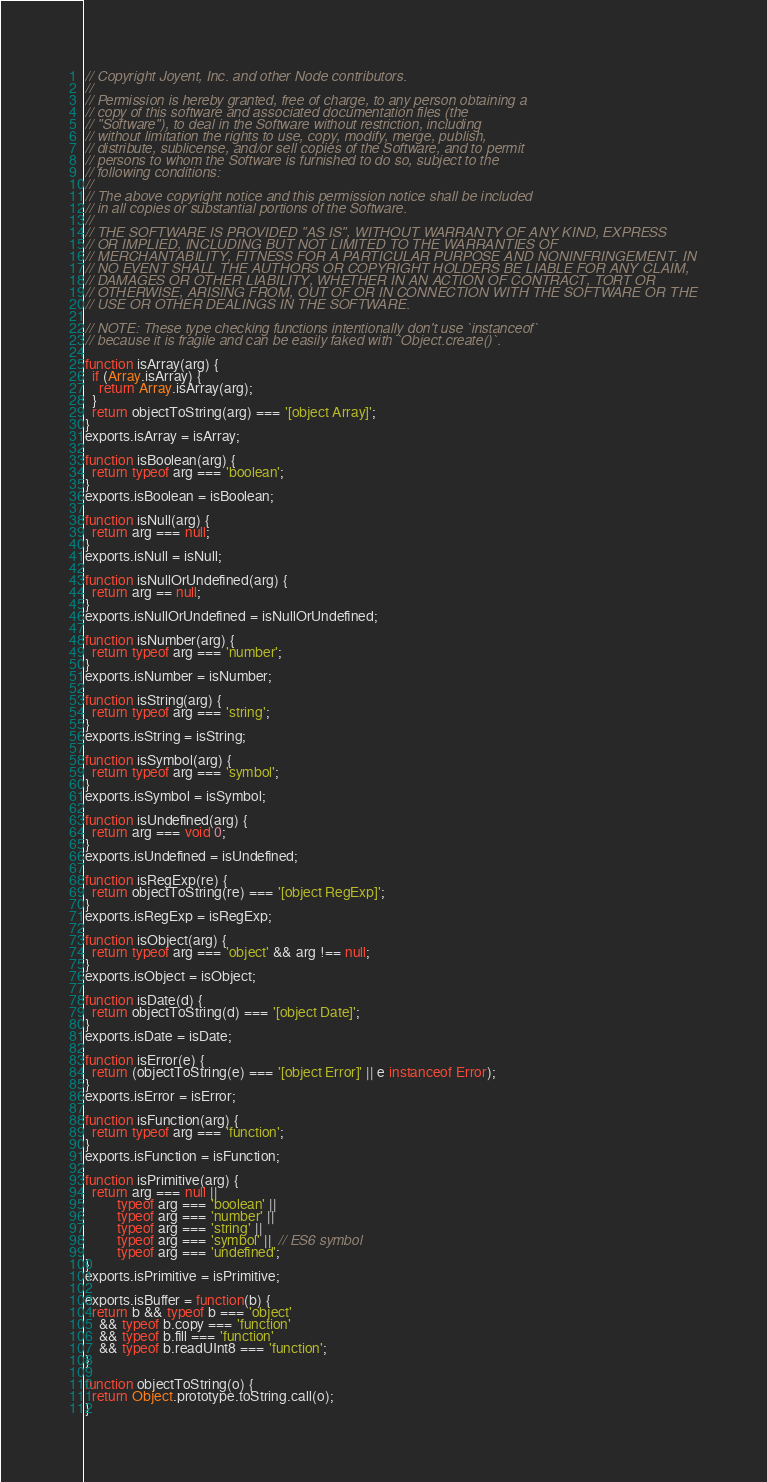Convert code to text. <code><loc_0><loc_0><loc_500><loc_500><_JavaScript_>// Copyright Joyent, Inc. and other Node contributors.
//
// Permission is hereby granted, free of charge, to any person obtaining a
// copy of this software and associated documentation files (the
// "Software"), to deal in the Software without restriction, including
// without limitation the rights to use, copy, modify, merge, publish,
// distribute, sublicense, and/or sell copies of the Software, and to permit
// persons to whom the Software is furnished to do so, subject to the
// following conditions:
//
// The above copyright notice and this permission notice shall be included
// in all copies or substantial portions of the Software.
//
// THE SOFTWARE IS PROVIDED "AS IS", WITHOUT WARRANTY OF ANY KIND, EXPRESS
// OR IMPLIED, INCLUDING BUT NOT LIMITED TO THE WARRANTIES OF
// MERCHANTABILITY, FITNESS FOR A PARTICULAR PURPOSE AND NONINFRINGEMENT. IN
// NO EVENT SHALL THE AUTHORS OR COPYRIGHT HOLDERS BE LIABLE FOR ANY CLAIM,
// DAMAGES OR OTHER LIABILITY, WHETHER IN AN ACTION OF CONTRACT, TORT OR
// OTHERWISE, ARISING FROM, OUT OF OR IN CONNECTION WITH THE SOFTWARE OR THE
// USE OR OTHER DEALINGS IN THE SOFTWARE.

// NOTE: These type checking functions intentionally don't use `instanceof`
// because it is fragile and can be easily faked with `Object.create()`.

function isArray(arg) {
  if (Array.isArray) {
    return Array.isArray(arg);
  }
  return objectToString(arg) === '[object Array]';
}
exports.isArray = isArray;

function isBoolean(arg) {
  return typeof arg === 'boolean';
}
exports.isBoolean = isBoolean;

function isNull(arg) {
  return arg === null;
}
exports.isNull = isNull;

function isNullOrUndefined(arg) {
  return arg == null;
}
exports.isNullOrUndefined = isNullOrUndefined;

function isNumber(arg) {
  return typeof arg === 'number';
}
exports.isNumber = isNumber;

function isString(arg) {
  return typeof arg === 'string';
}
exports.isString = isString;

function isSymbol(arg) {
  return typeof arg === 'symbol';
}
exports.isSymbol = isSymbol;

function isUndefined(arg) {
  return arg === void 0;
}
exports.isUndefined = isUndefined;

function isRegExp(re) {
  return objectToString(re) === '[object RegExp]';
}
exports.isRegExp = isRegExp;

function isObject(arg) {
  return typeof arg === 'object' && arg !== null;
}
exports.isObject = isObject;

function isDate(d) {
  return objectToString(d) === '[object Date]';
}
exports.isDate = isDate;

function isError(e) {
  return (objectToString(e) === '[object Error]' || e instanceof Error);
}
exports.isError = isError;

function isFunction(arg) {
  return typeof arg === 'function';
}
exports.isFunction = isFunction;

function isPrimitive(arg) {
  return arg === null ||
         typeof arg === 'boolean' ||
         typeof arg === 'number' ||
         typeof arg === 'string' ||
         typeof arg === 'symbol' ||  // ES6 symbol
         typeof arg === 'undefined';
}
exports.isPrimitive = isPrimitive;

exports.isBuffer = function(b) {
  return b && typeof b === 'object'
    && typeof b.copy === 'function'
    && typeof b.fill === 'function'
    && typeof b.readUInt8 === 'function';
}

function objectToString(o) {
  return Object.prototype.toString.call(o);
}
</code> 